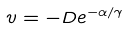<formula> <loc_0><loc_0><loc_500><loc_500>v = - D e ^ { - \alpha / \gamma }</formula> 